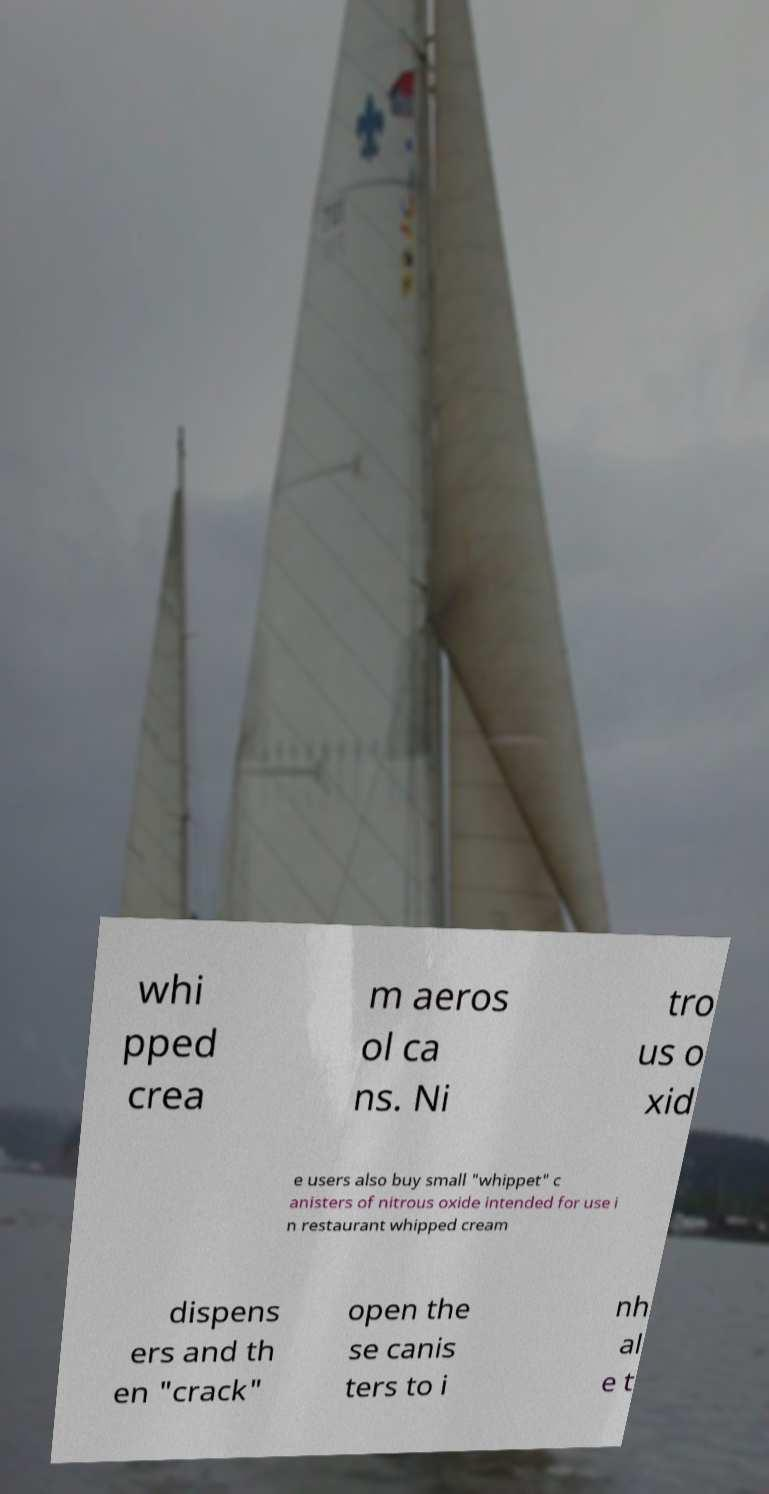Please read and relay the text visible in this image. What does it say? whi pped crea m aeros ol ca ns. Ni tro us o xid e users also buy small "whippet" c anisters of nitrous oxide intended for use i n restaurant whipped cream dispens ers and th en "crack" open the se canis ters to i nh al e t 